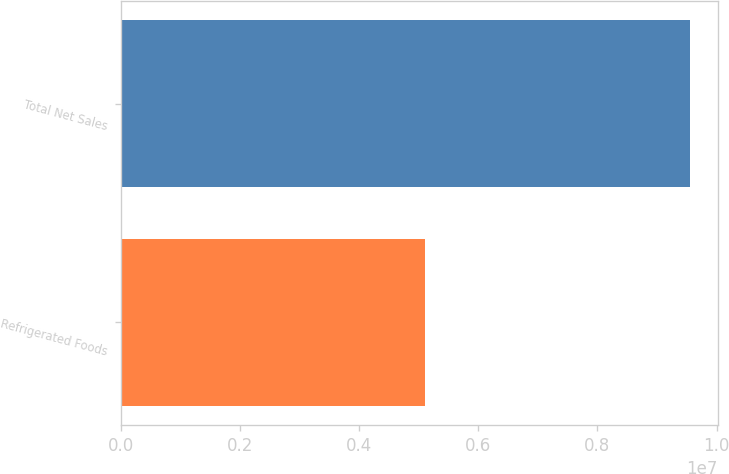<chart> <loc_0><loc_0><loc_500><loc_500><bar_chart><fcel>Refrigerated Foods<fcel>Total Net Sales<nl><fcel>5.10988e+06<fcel>9.5457e+06<nl></chart> 